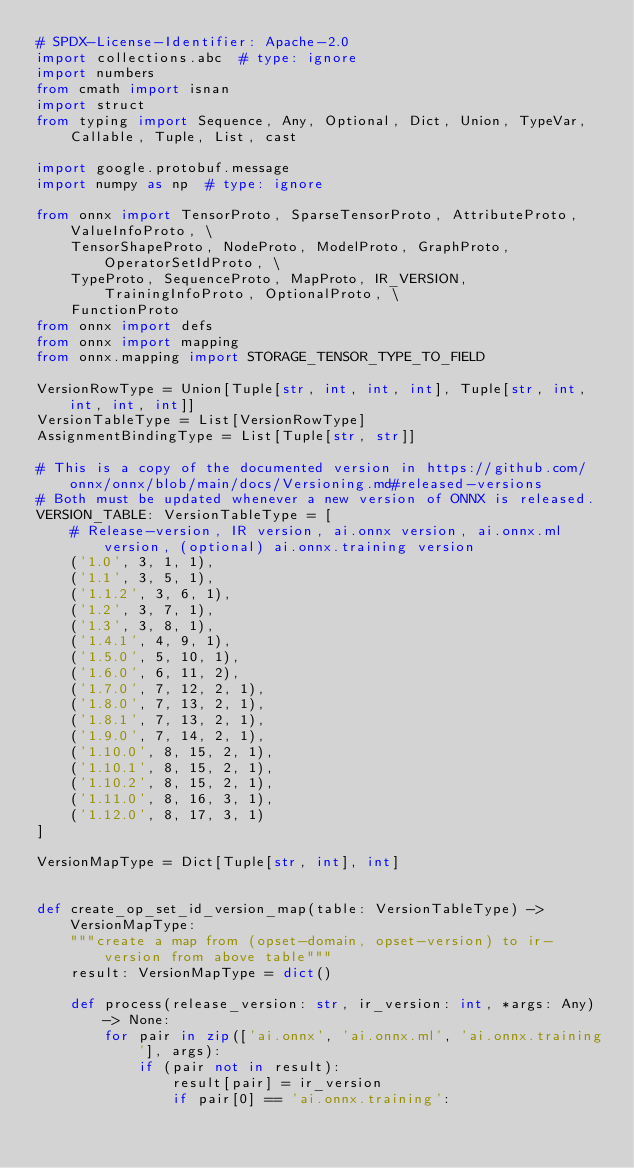Convert code to text. <code><loc_0><loc_0><loc_500><loc_500><_Python_># SPDX-License-Identifier: Apache-2.0
import collections.abc  # type: ignore
import numbers
from cmath import isnan
import struct
from typing import Sequence, Any, Optional, Dict, Union, TypeVar, Callable, Tuple, List, cast

import google.protobuf.message
import numpy as np  # type: ignore

from onnx import TensorProto, SparseTensorProto, AttributeProto, ValueInfoProto, \
    TensorShapeProto, NodeProto, ModelProto, GraphProto, OperatorSetIdProto, \
    TypeProto, SequenceProto, MapProto, IR_VERSION, TrainingInfoProto, OptionalProto, \
    FunctionProto
from onnx import defs
from onnx import mapping
from onnx.mapping import STORAGE_TENSOR_TYPE_TO_FIELD

VersionRowType = Union[Tuple[str, int, int, int], Tuple[str, int, int, int, int]]
VersionTableType = List[VersionRowType]
AssignmentBindingType = List[Tuple[str, str]]

# This is a copy of the documented version in https://github.com/onnx/onnx/blob/main/docs/Versioning.md#released-versions
# Both must be updated whenever a new version of ONNX is released.
VERSION_TABLE: VersionTableType = [
    # Release-version, IR version, ai.onnx version, ai.onnx.ml version, (optional) ai.onnx.training version
    ('1.0', 3, 1, 1),
    ('1.1', 3, 5, 1),
    ('1.1.2', 3, 6, 1),
    ('1.2', 3, 7, 1),
    ('1.3', 3, 8, 1),
    ('1.4.1', 4, 9, 1),
    ('1.5.0', 5, 10, 1),
    ('1.6.0', 6, 11, 2),
    ('1.7.0', 7, 12, 2, 1),
    ('1.8.0', 7, 13, 2, 1),
    ('1.8.1', 7, 13, 2, 1),
    ('1.9.0', 7, 14, 2, 1),
    ('1.10.0', 8, 15, 2, 1),
    ('1.10.1', 8, 15, 2, 1),
    ('1.10.2', 8, 15, 2, 1),
    ('1.11.0', 8, 16, 3, 1),
    ('1.12.0', 8, 17, 3, 1)
]

VersionMapType = Dict[Tuple[str, int], int]


def create_op_set_id_version_map(table: VersionTableType) -> VersionMapType:
    """create a map from (opset-domain, opset-version) to ir-version from above table"""
    result: VersionMapType = dict()

    def process(release_version: str, ir_version: int, *args: Any) -> None:
        for pair in zip(['ai.onnx', 'ai.onnx.ml', 'ai.onnx.training'], args):
            if (pair not in result):
                result[pair] = ir_version
                if pair[0] == 'ai.onnx.training':</code> 